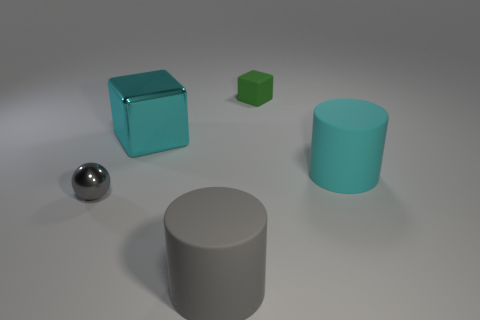There is a thing that is both in front of the rubber cube and behind the cyan matte object; what material is it?
Your answer should be very brief. Metal. Is the size of the cyan object that is on the right side of the cyan metallic thing the same as the tiny metal thing?
Offer a terse response. No. Is the color of the rubber cube the same as the small sphere?
Your response must be concise. No. How many big objects are in front of the gray metal ball and behind the tiny metal sphere?
Provide a short and direct response. 0. There is a big matte cylinder that is on the left side of the thing that is behind the cyan cube; how many gray balls are in front of it?
Provide a succinct answer. 0. There is a rubber object that is the same color as the large block; what is its size?
Ensure brevity in your answer.  Large. The large gray thing has what shape?
Your response must be concise. Cylinder. How many cyan cubes have the same material as the small gray object?
Your answer should be compact. 1. The thing that is made of the same material as the gray sphere is what color?
Ensure brevity in your answer.  Cyan. There is a green object; is its size the same as the cylinder that is behind the large gray object?
Your answer should be compact. No. 